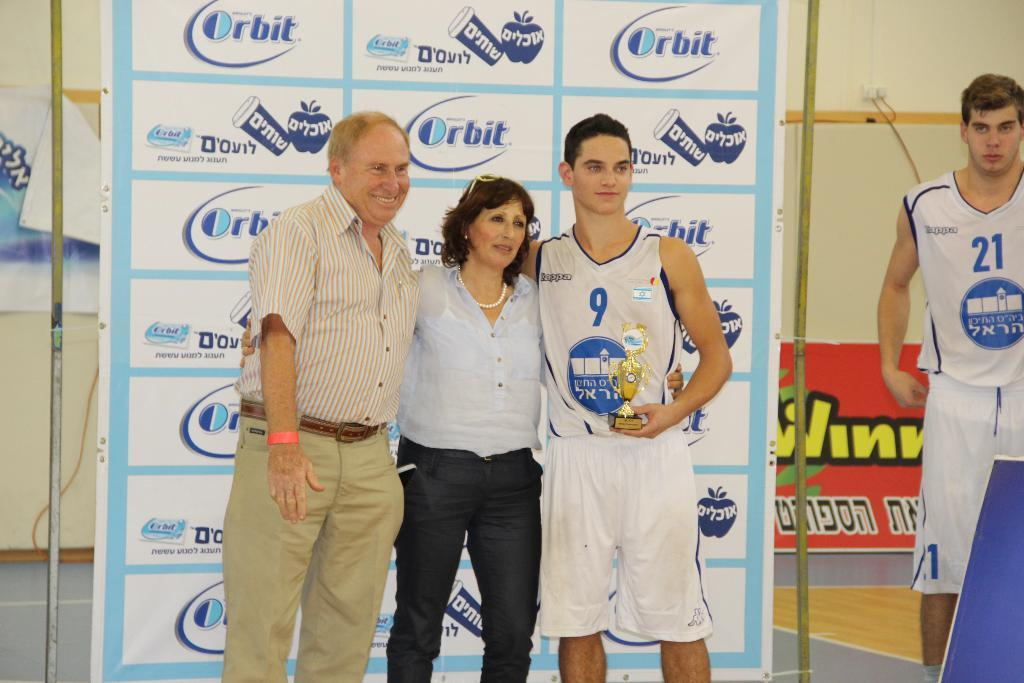<image>
Give a short and clear explanation of the subsequent image. Player #9 won the MVP award at the basketball game. 